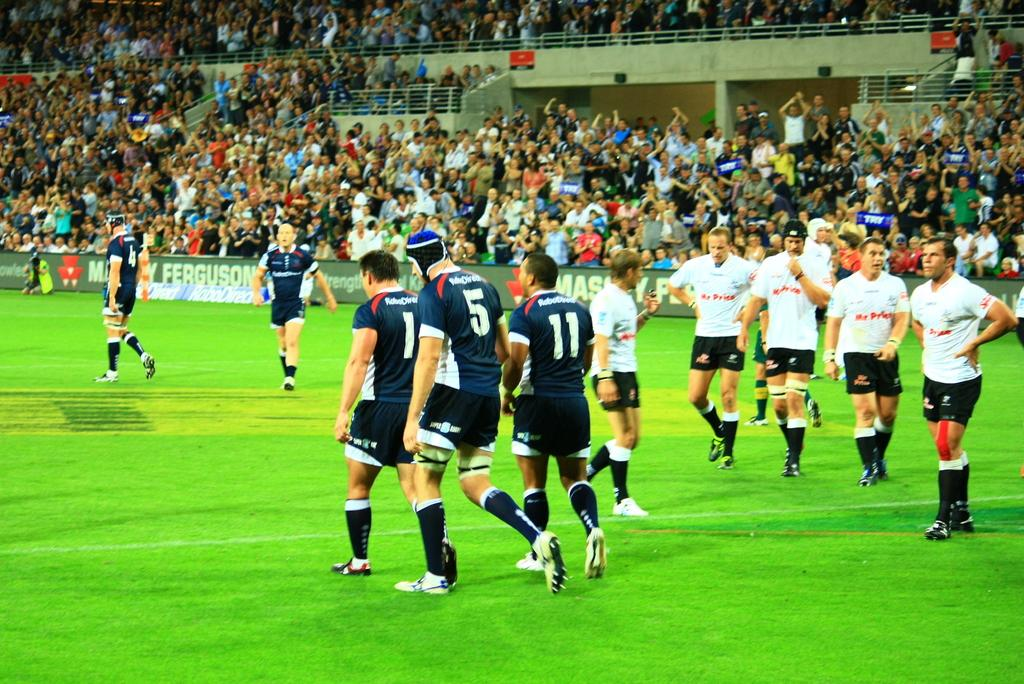What is the main setting of the image? The main setting of the image is a stadium with many people. What can be seen in the background of the image? There is a banner with text in the background of the image. What are the people on the ground doing in the image? The people on the ground are likely attending an event or gathering at the stadium. What type of structure is present in the image? There are railings in the image. What type of bat is flying around in the image? There is no bat present in the image. What type of collar is visible on the people in the image? The people in the image are not wearing collars; they are likely dressed in casual or event-appropriate attire. 